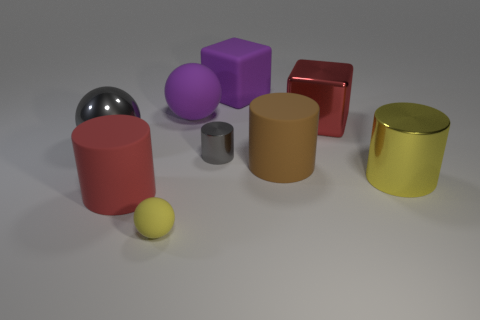There is a object that is the same color as the metal cube; what size is it?
Provide a succinct answer. Large. Is there a rubber thing of the same color as the large shiny block?
Provide a succinct answer. Yes. What is the shape of the red metallic object?
Offer a terse response. Cube. Do the rubber block and the matte ball behind the small gray object have the same color?
Provide a short and direct response. Yes. Is the number of gray metallic things behind the purple rubber cube the same as the number of big brown matte balls?
Make the answer very short. Yes. What number of red cubes have the same size as the red cylinder?
Your response must be concise. 1. There is a big thing that is the same color as the small rubber sphere; what is its shape?
Your response must be concise. Cylinder. Are there any large red cylinders?
Offer a terse response. Yes. Is the shape of the red thing behind the gray shiny cylinder the same as the large purple object that is behind the purple matte ball?
Ensure brevity in your answer.  Yes. What number of large things are yellow metallic things or purple metallic cylinders?
Give a very brief answer. 1. 